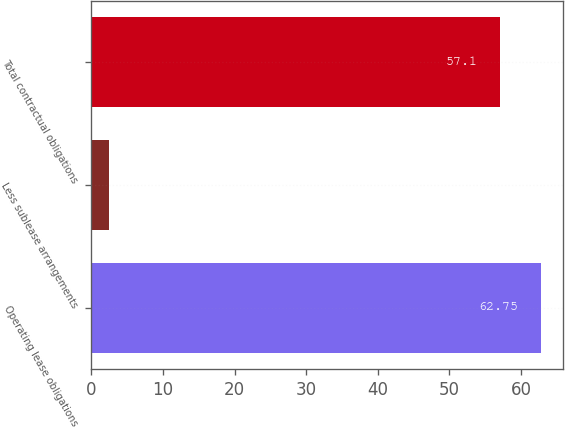Convert chart to OTSL. <chart><loc_0><loc_0><loc_500><loc_500><bar_chart><fcel>Operating lease obligations<fcel>Less sublease arrangements<fcel>Total contractual obligations<nl><fcel>62.75<fcel>2.5<fcel>57.1<nl></chart> 